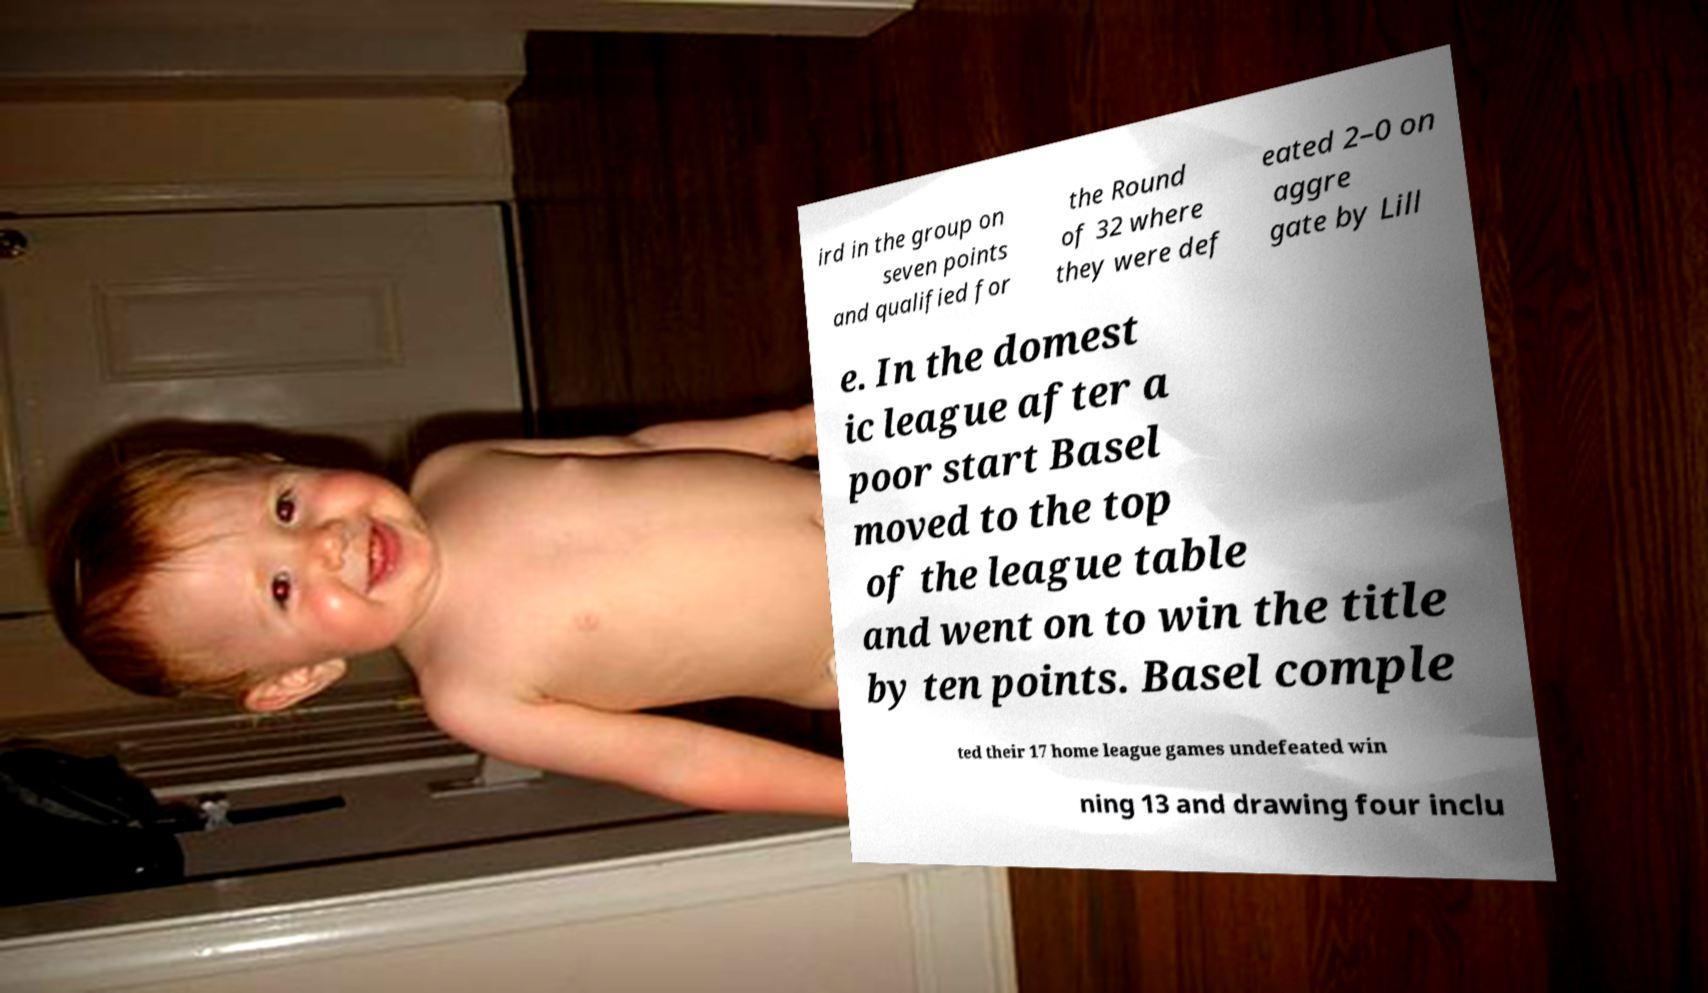Please read and relay the text visible in this image. What does it say? ird in the group on seven points and qualified for the Round of 32 where they were def eated 2–0 on aggre gate by Lill e. In the domest ic league after a poor start Basel moved to the top of the league table and went on to win the title by ten points. Basel comple ted their 17 home league games undefeated win ning 13 and drawing four inclu 